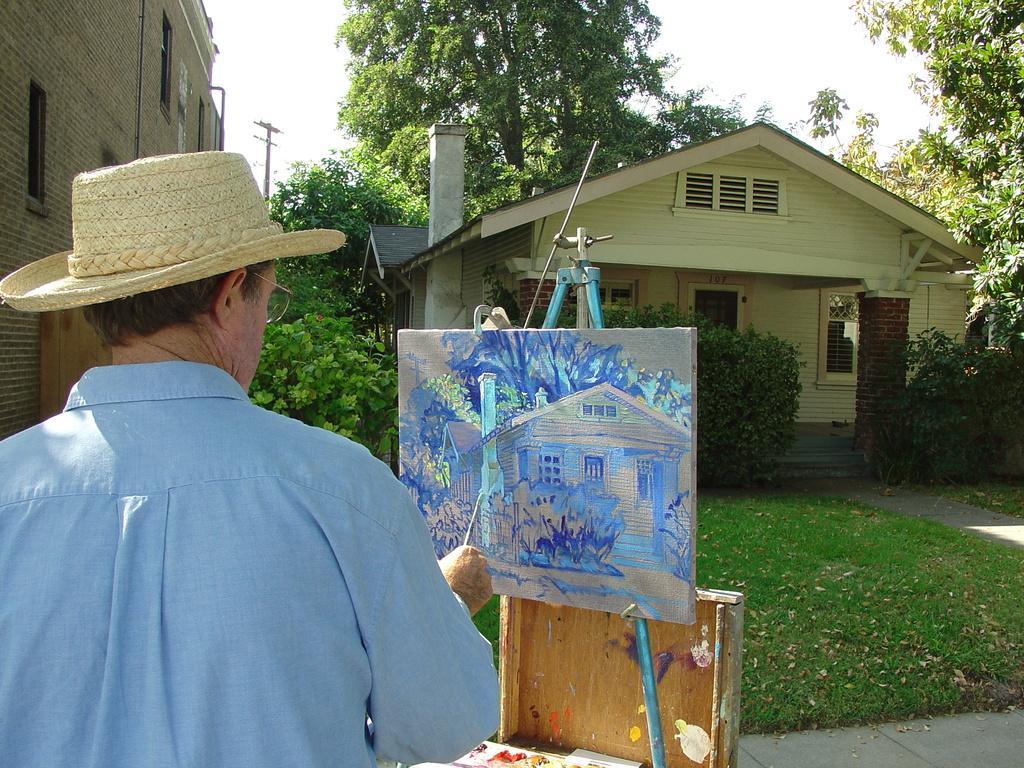Can you describe this image briefly? In this image we can see a person painting on an object. There are many trees and plants in the image. There is a house at the right side of the image. There is a building and an electrical pole at the left side of the image. There is a grassy land in the image. 